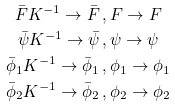Convert formula to latex. <formula><loc_0><loc_0><loc_500><loc_500>\bar { F } K ^ { - 1 } \to \bar { F } \, , & \, F \to F \\ \bar { \psi } K ^ { - 1 } \to \bar { \psi } \, , & \, \psi \to \psi \\ \bar { \phi } _ { 1 } K ^ { - 1 } \to \bar { \phi } _ { 1 } \, , & \, \phi _ { 1 } \to \phi _ { 1 } \\ \bar { \phi } _ { 2 } K ^ { - 1 } \to \bar { \phi } _ { 2 } \, , & \, \phi _ { 2 } \to \phi _ { 2 }</formula> 